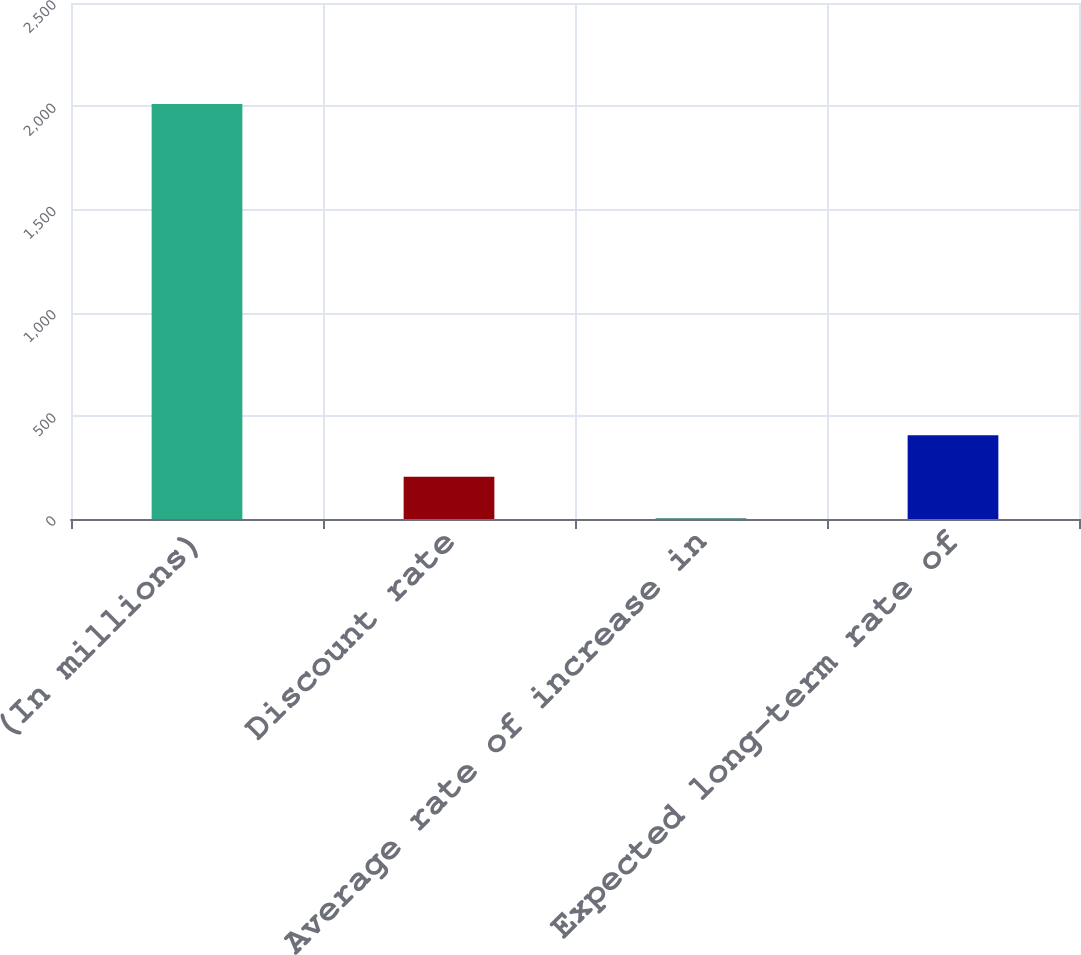Convert chart. <chart><loc_0><loc_0><loc_500><loc_500><bar_chart><fcel>(In millions)<fcel>Discount rate<fcel>Average rate of increase in<fcel>Expected long-term rate of<nl><fcel>2011<fcel>204.7<fcel>4<fcel>405.4<nl></chart> 